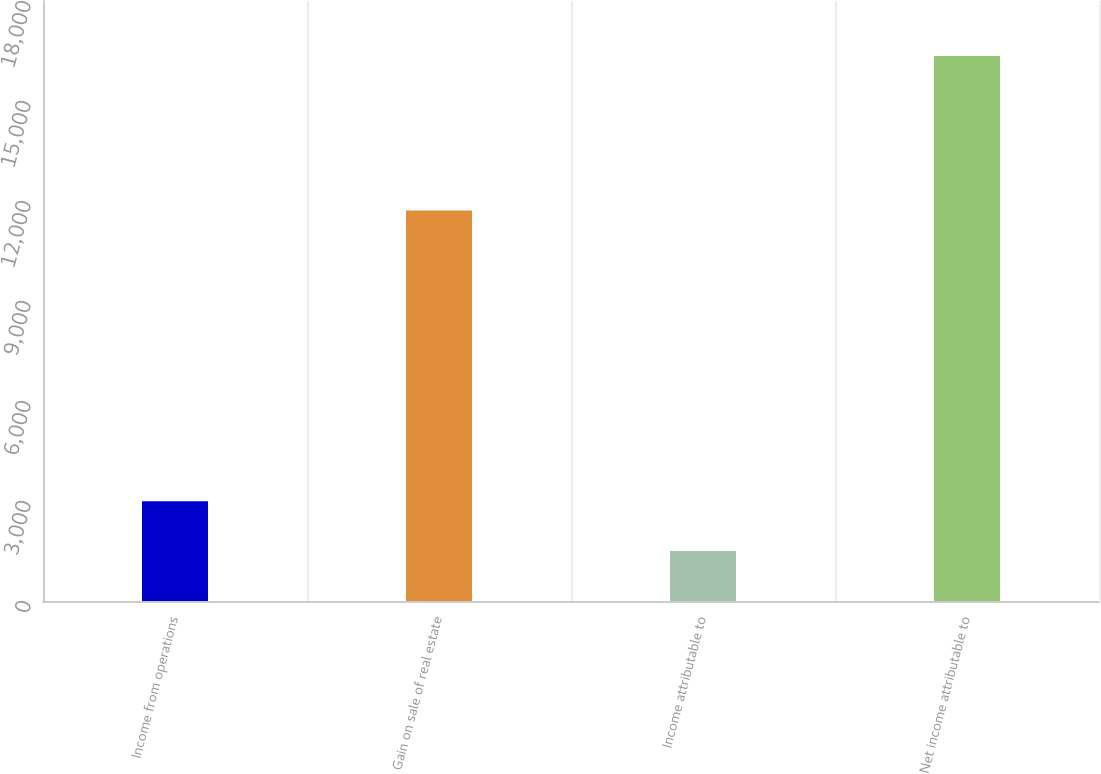Convert chart to OTSL. <chart><loc_0><loc_0><loc_500><loc_500><bar_chart><fcel>Income from operations<fcel>Gain on sale of real estate<fcel>Income attributable to<fcel>Net income attributable to<nl><fcel>2990.2<fcel>11715<fcel>1503.6<fcel>16352.6<nl></chart> 